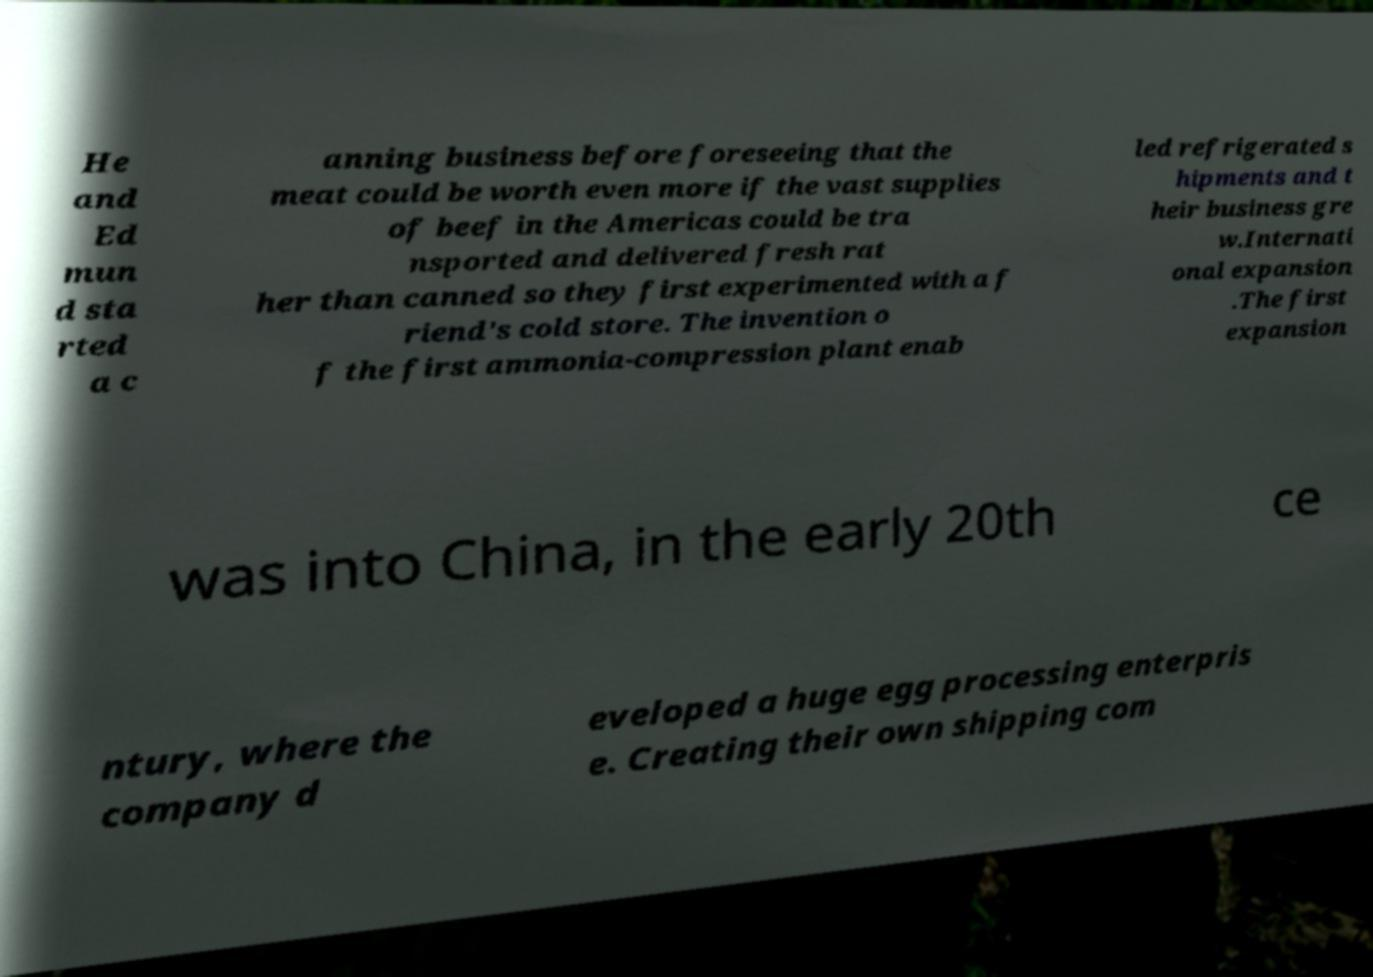Please identify and transcribe the text found in this image. He and Ed mun d sta rted a c anning business before foreseeing that the meat could be worth even more if the vast supplies of beef in the Americas could be tra nsported and delivered fresh rat her than canned so they first experimented with a f riend's cold store. The invention o f the first ammonia-compression plant enab led refrigerated s hipments and t heir business gre w.Internati onal expansion .The first expansion was into China, in the early 20th ce ntury, where the company d eveloped a huge egg processing enterpris e. Creating their own shipping com 